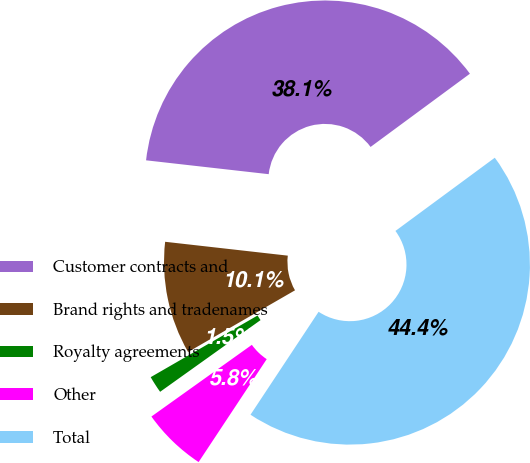Convert chart to OTSL. <chart><loc_0><loc_0><loc_500><loc_500><pie_chart><fcel>Customer contracts and<fcel>Brand rights and tradenames<fcel>Royalty agreements<fcel>Other<fcel>Total<nl><fcel>38.1%<fcel>10.12%<fcel>1.54%<fcel>5.83%<fcel>44.41%<nl></chart> 